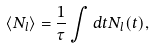<formula> <loc_0><loc_0><loc_500><loc_500>\langle N _ { l } \rangle = \frac { 1 } { \tau } \int d t N _ { l } ( t ) ,</formula> 